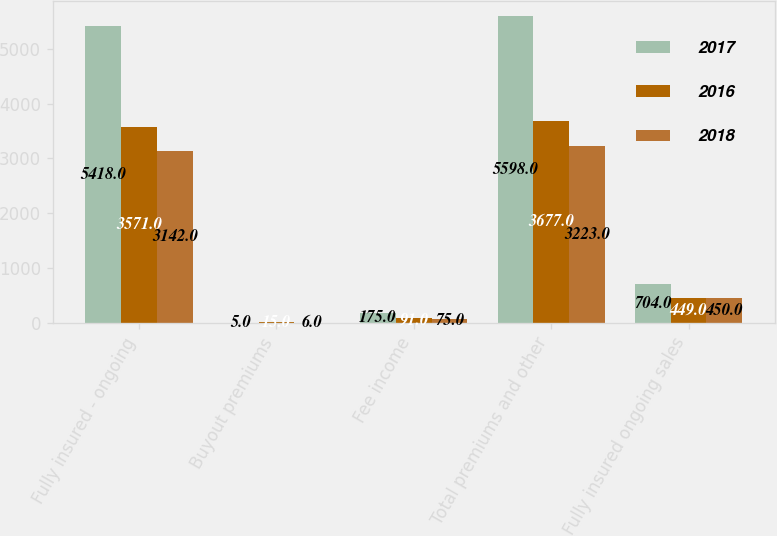Convert chart. <chart><loc_0><loc_0><loc_500><loc_500><stacked_bar_chart><ecel><fcel>Fully insured - ongoing<fcel>Buyout premiums<fcel>Fee income<fcel>Total premiums and other<fcel>Fully insured ongoing sales<nl><fcel>2017<fcel>5418<fcel>5<fcel>175<fcel>5598<fcel>704<nl><fcel>2016<fcel>3571<fcel>15<fcel>91<fcel>3677<fcel>449<nl><fcel>2018<fcel>3142<fcel>6<fcel>75<fcel>3223<fcel>450<nl></chart> 